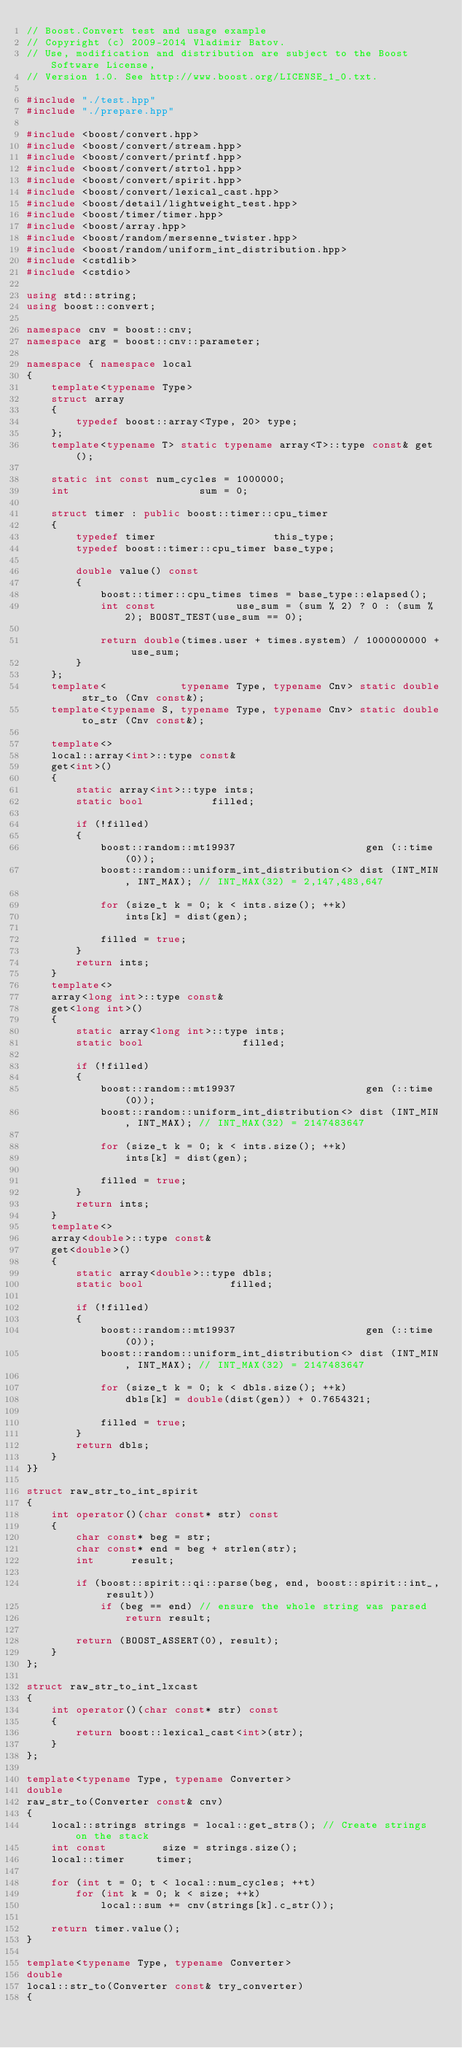<code> <loc_0><loc_0><loc_500><loc_500><_C++_>// Boost.Convert test and usage example
// Copyright (c) 2009-2014 Vladimir Batov.
// Use, modification and distribution are subject to the Boost Software License,
// Version 1.0. See http://www.boost.org/LICENSE_1_0.txt.

#include "./test.hpp"
#include "./prepare.hpp"

#include <boost/convert.hpp>
#include <boost/convert/stream.hpp>
#include <boost/convert/printf.hpp>
#include <boost/convert/strtol.hpp>
#include <boost/convert/spirit.hpp>
#include <boost/convert/lexical_cast.hpp>
#include <boost/detail/lightweight_test.hpp>
#include <boost/timer/timer.hpp>
#include <boost/array.hpp>
#include <boost/random/mersenne_twister.hpp>
#include <boost/random/uniform_int_distribution.hpp>
#include <cstdlib>
#include <cstdio>

using std::string;
using boost::convert;

namespace cnv = boost::cnv;
namespace arg = boost::cnv::parameter;

namespace { namespace local
{
    template<typename Type>
    struct array
    {
        typedef boost::array<Type, 20> type;
    };
    template<typename T> static typename array<T>::type const& get();

    static int const num_cycles = 1000000;
    int                     sum = 0;

    struct timer : public boost::timer::cpu_timer
    {
        typedef timer                   this_type;
        typedef boost::timer::cpu_timer base_type;

        double value() const
        {
            boost::timer::cpu_times times = base_type::elapsed();
            int const             use_sum = (sum % 2) ? 0 : (sum % 2); BOOST_TEST(use_sum == 0);

            return double(times.user + times.system) / 1000000000 + use_sum;
        }
    };
    template<            typename Type, typename Cnv> static double str_to (Cnv const&);
    template<typename S, typename Type, typename Cnv> static double to_str (Cnv const&);

    template<>
    local::array<int>::type const&
    get<int>()
    {
        static array<int>::type ints;
        static bool           filled;

        if (!filled)
        {
            boost::random::mt19937                     gen (::time(0));
            boost::random::uniform_int_distribution<> dist (INT_MIN, INT_MAX); // INT_MAX(32) = 2,147,483,647

            for (size_t k = 0; k < ints.size(); ++k)
                ints[k] = dist(gen);

            filled = true;
        }
        return ints;
    }
    template<>
    array<long int>::type const&
    get<long int>()
    {
        static array<long int>::type ints;
        static bool                filled;

        if (!filled)
        {
            boost::random::mt19937                     gen (::time(0));
            boost::random::uniform_int_distribution<> dist (INT_MIN, INT_MAX); // INT_MAX(32) = 2147483647

            for (size_t k = 0; k < ints.size(); ++k)
                ints[k] = dist(gen);

            filled = true;
        }
        return ints;
    }
    template<>
    array<double>::type const&
    get<double>()
    {
        static array<double>::type dbls;
        static bool              filled;

        if (!filled)
        {
            boost::random::mt19937                     gen (::time(0));
            boost::random::uniform_int_distribution<> dist (INT_MIN, INT_MAX); // INT_MAX(32) = 2147483647

            for (size_t k = 0; k < dbls.size(); ++k)
                dbls[k] = double(dist(gen)) + 0.7654321;

            filled = true;
        }
        return dbls;
    }
}}

struct raw_str_to_int_spirit
{
    int operator()(char const* str) const
    {
        char const* beg = str;
        char const* end = beg + strlen(str);
        int      result;

        if (boost::spirit::qi::parse(beg, end, boost::spirit::int_, result))
            if (beg == end) // ensure the whole string was parsed
                return result;

        return (BOOST_ASSERT(0), result);
    }
};

struct raw_str_to_int_lxcast
{
    int operator()(char const* str) const
    {
        return boost::lexical_cast<int>(str);
    }
};

template<typename Type, typename Converter>
double
raw_str_to(Converter const& cnv)
{
    local::strings strings = local::get_strs(); // Create strings on the stack
    int const         size = strings.size();
    local::timer     timer;

    for (int t = 0; t < local::num_cycles; ++t)
        for (int k = 0; k < size; ++k)
            local::sum += cnv(strings[k].c_str());

    return timer.value();
}

template<typename Type, typename Converter>
double
local::str_to(Converter const& try_converter)
{</code> 